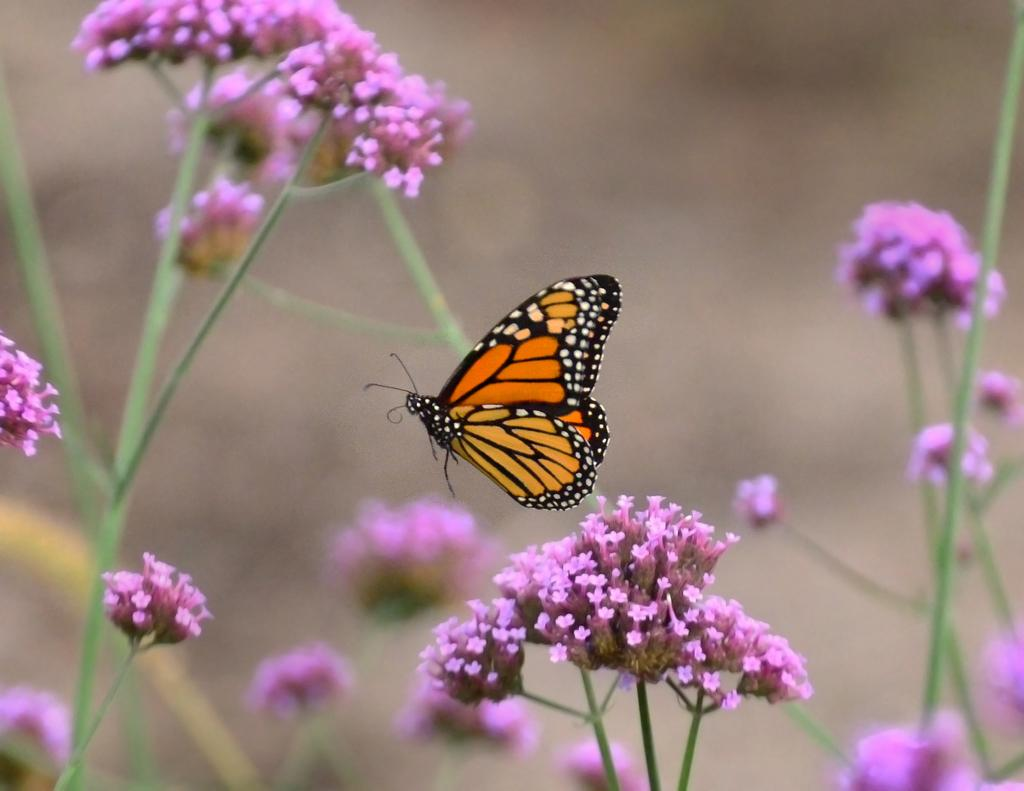What is the main subject of the image? There is a butterfly in the image. What is the butterfly doing in the image? The butterfly is flying in the air. What type of flowers can be seen in the image? There are pink flowers in the image. What else can be seen in the image besides the butterfly and flowers? There are branches in the image. How would you describe the background of the image? The background of the image is blurred. What type of beginner's course is being offered in the image? There is no indication of a course or any educational material in the image, as it features a butterfly flying near pink flowers and branches with a blurred background. 